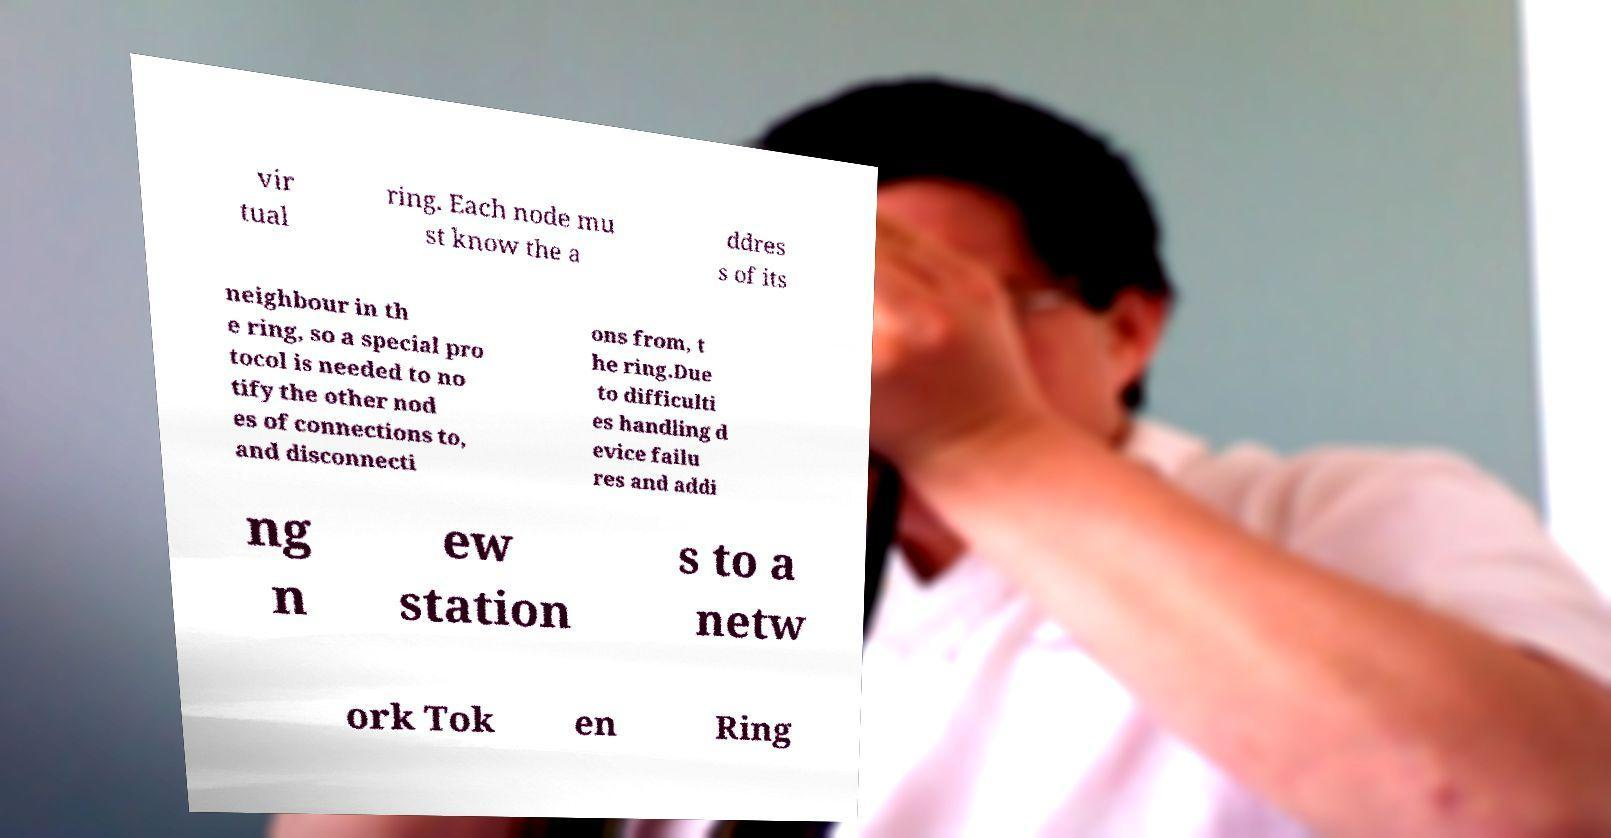For documentation purposes, I need the text within this image transcribed. Could you provide that? vir tual ring. Each node mu st know the a ddres s of its neighbour in th e ring, so a special pro tocol is needed to no tify the other nod es of connections to, and disconnecti ons from, t he ring.Due to difficulti es handling d evice failu res and addi ng n ew station s to a netw ork Tok en Ring 